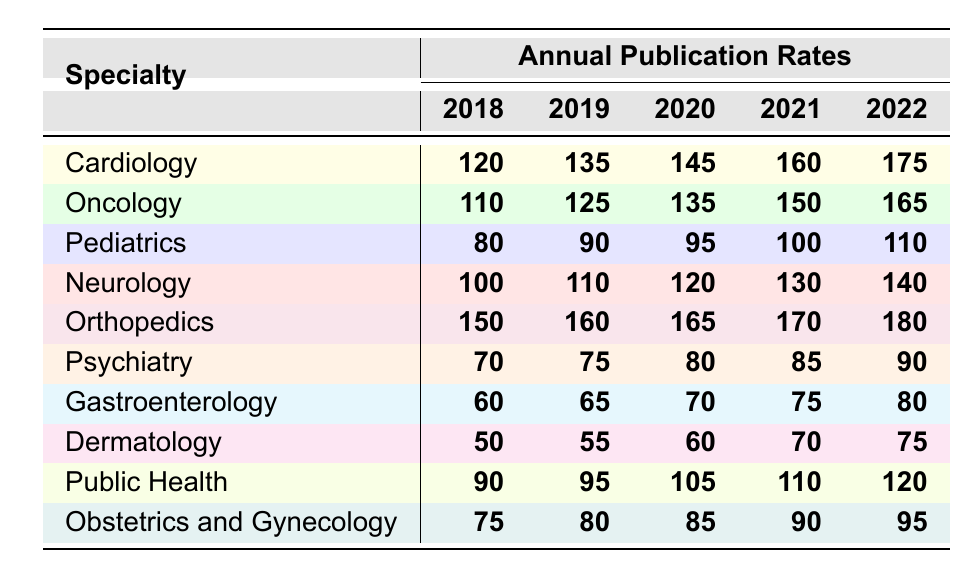What was the annual publication rate in Cardiology in 2021? By locating the row for Cardiology and then identifying the 2021 column, we see the value listed there is 160.
Answer: 160 How many publications were there in Pediatrics in 2022? Referring to the Pediatrics row and the 2022 column, the number of publications is 110.
Answer: 110 Which specialty had the highest annual publication rate in 2022? By reviewing the publication rates in 2022 for all specialties, Orthopedics has the highest number at 180.
Answer: Orthopedics What was the difference in the number of publications in Psychiatry from 2018 to 2022? The publication rates for Psychiatry in 2018 is 70, and in 2022 it is 90. The difference is 90 - 70 = 20.
Answer: 20 What is the average annual publication rate for Gastroenterology over the five years? The publication rates for Gastroenterology from 2018 to 2022 are 60, 65, 70, 75, and 80. Summing these gives 350, and dividing by 5 yields an average of 70.
Answer: 70 Was the publication rate for Neurology higher in 2021 or 2020? The rates show Neurology had 130 publications in 2021 and 120 in 2020; hence, 130 is higher.
Answer: Yes, 2021 was higher Which specialty saw the most significant increase in publications between 2018 and 2022? Observing the publication rates, Cardiology increased from 120 to 175 (a change of 55), Orthopedics from 150 to 180 (a change of 30), which is the largest increase.
Answer: Cardiology What was the total number of publications in Public Health from 2018 to 2022? Summing the publications for Public Health in the years listed: 90 + 95 + 105 + 110 + 120 gives a total of 520.
Answer: 520 How many more publications were there in Orthopedics in 2022 compared to Obstetrics and Gynecology? Orthopedics had 180 publications in 2022, and Obstetrics and Gynecology had 95. The difference is 180 - 95 = 85.
Answer: 85 Is it true that Dermatology had more publications than Gastroenterology in 2019? In 2019, Dermatology had 55 publications and Gastroenterology had 65. Since 55 is less than 65, this statement is false.
Answer: No 